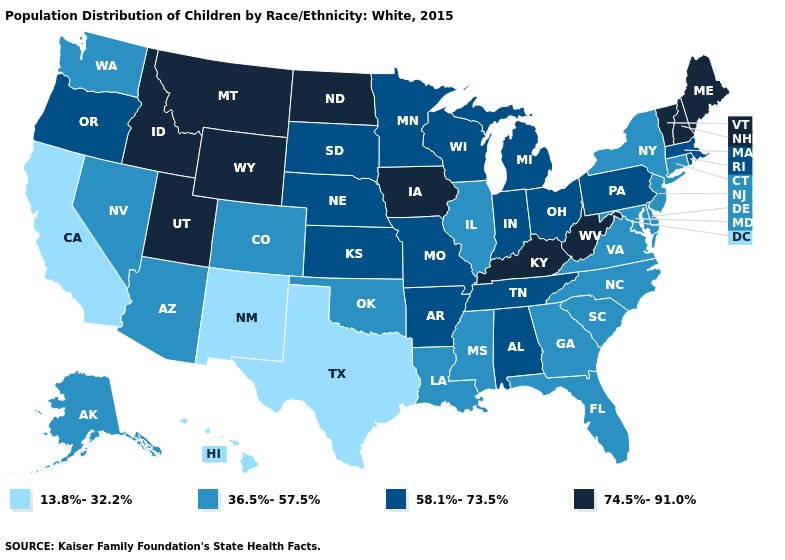What is the value of New Hampshire?
Quick response, please. 74.5%-91.0%. Name the states that have a value in the range 13.8%-32.2%?
Answer briefly. California, Hawaii, New Mexico, Texas. Is the legend a continuous bar?
Give a very brief answer. No. Does the first symbol in the legend represent the smallest category?
Answer briefly. Yes. Name the states that have a value in the range 13.8%-32.2%?
Answer briefly. California, Hawaii, New Mexico, Texas. What is the value of Tennessee?
Be succinct. 58.1%-73.5%. Which states hav the highest value in the MidWest?
Short answer required. Iowa, North Dakota. Name the states that have a value in the range 58.1%-73.5%?
Concise answer only. Alabama, Arkansas, Indiana, Kansas, Massachusetts, Michigan, Minnesota, Missouri, Nebraska, Ohio, Oregon, Pennsylvania, Rhode Island, South Dakota, Tennessee, Wisconsin. Is the legend a continuous bar?
Give a very brief answer. No. What is the highest value in states that border Utah?
Keep it brief. 74.5%-91.0%. Name the states that have a value in the range 74.5%-91.0%?
Write a very short answer. Idaho, Iowa, Kentucky, Maine, Montana, New Hampshire, North Dakota, Utah, Vermont, West Virginia, Wyoming. What is the value of New Mexico?
Give a very brief answer. 13.8%-32.2%. Name the states that have a value in the range 36.5%-57.5%?
Quick response, please. Alaska, Arizona, Colorado, Connecticut, Delaware, Florida, Georgia, Illinois, Louisiana, Maryland, Mississippi, Nevada, New Jersey, New York, North Carolina, Oklahoma, South Carolina, Virginia, Washington. Which states have the lowest value in the USA?
Answer briefly. California, Hawaii, New Mexico, Texas. Does Mississippi have a higher value than Oklahoma?
Answer briefly. No. 